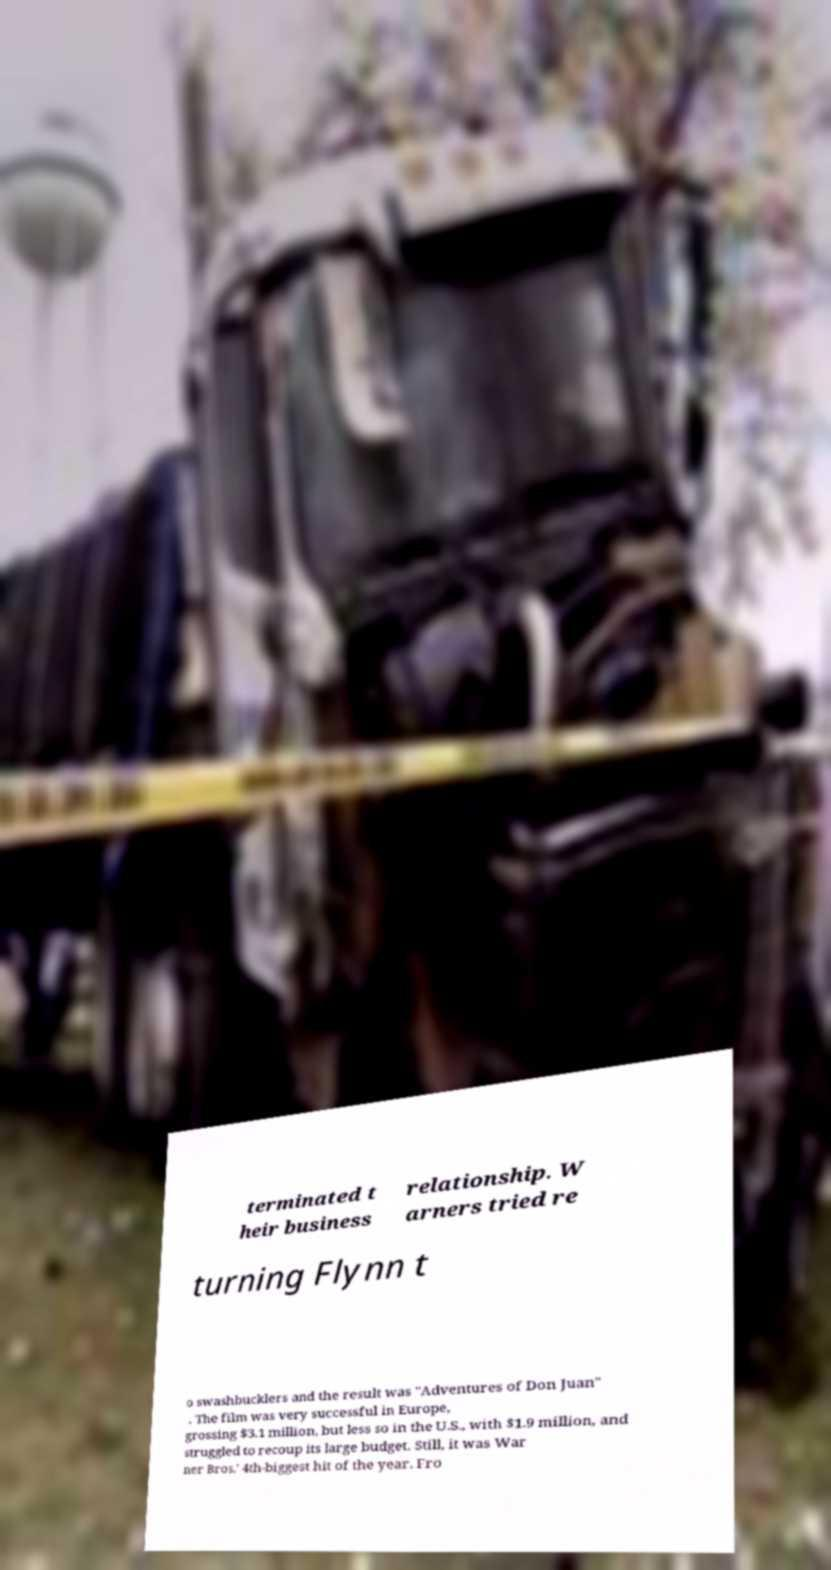Could you extract and type out the text from this image? terminated t heir business relationship. W arners tried re turning Flynn t o swashbucklers and the result was "Adventures of Don Juan" . The film was very successful in Europe, grossing $3.1 million, but less so in the U.S., with $1.9 million, and struggled to recoup its large budget. Still, it was War ner Bros.' 4th-biggest hit of the year. Fro 